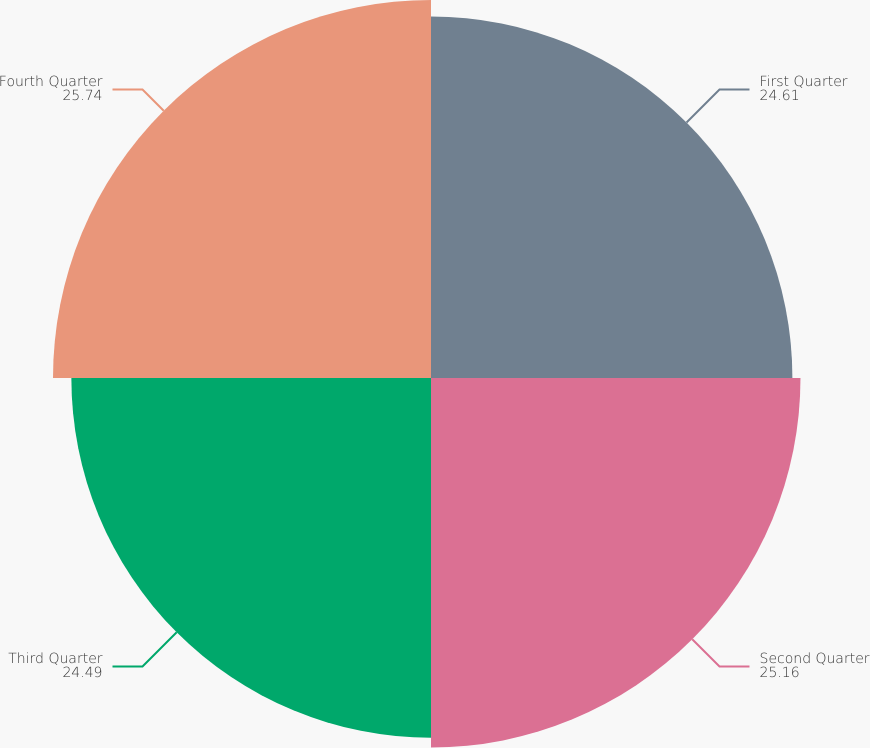<chart> <loc_0><loc_0><loc_500><loc_500><pie_chart><fcel>First Quarter<fcel>Second Quarter<fcel>Third Quarter<fcel>Fourth Quarter<nl><fcel>24.61%<fcel>25.16%<fcel>24.49%<fcel>25.74%<nl></chart> 